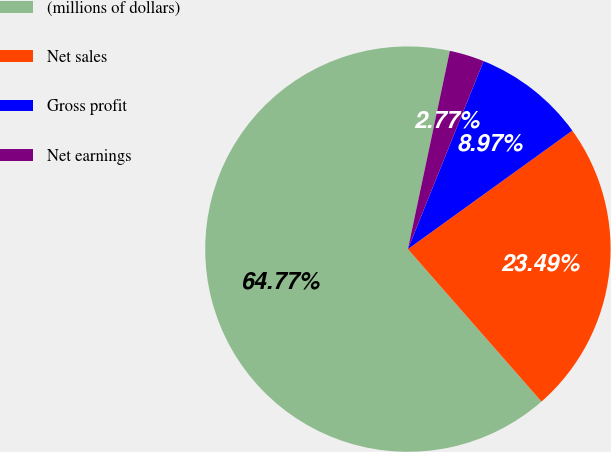Convert chart to OTSL. <chart><loc_0><loc_0><loc_500><loc_500><pie_chart><fcel>(millions of dollars)<fcel>Net sales<fcel>Gross profit<fcel>Net earnings<nl><fcel>64.77%<fcel>23.49%<fcel>8.97%<fcel>2.77%<nl></chart> 